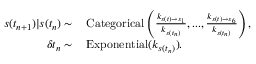<formula> <loc_0><loc_0><loc_500><loc_500>\begin{array} { r l } { s ( t _ { n + 1 } ) | s ( t _ { n } ) \sim } & \, C a t e g o r i c a l \left ( \frac { k _ { s ( t ) \rightarrow s _ { 1 } } } { k _ { s ( t _ { n } ) } } , \dots , \frac { k _ { s ( t ) \rightarrow s _ { 6 } } } { k _ { s ( t _ { n } ) } } \right ) , } \\ { \delta t _ { n } \sim } & \, E x p o n e n t i a l ( k _ { s ( t _ { n } ) } ) . } \end{array}</formula> 